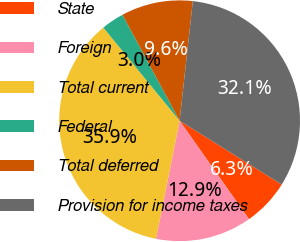Convert chart to OTSL. <chart><loc_0><loc_0><loc_500><loc_500><pie_chart><fcel>State<fcel>Foreign<fcel>Total current<fcel>Federal<fcel>Total deferred<fcel>Provision for income taxes<nl><fcel>6.34%<fcel>12.91%<fcel>35.94%<fcel>3.05%<fcel>9.62%<fcel>32.14%<nl></chart> 